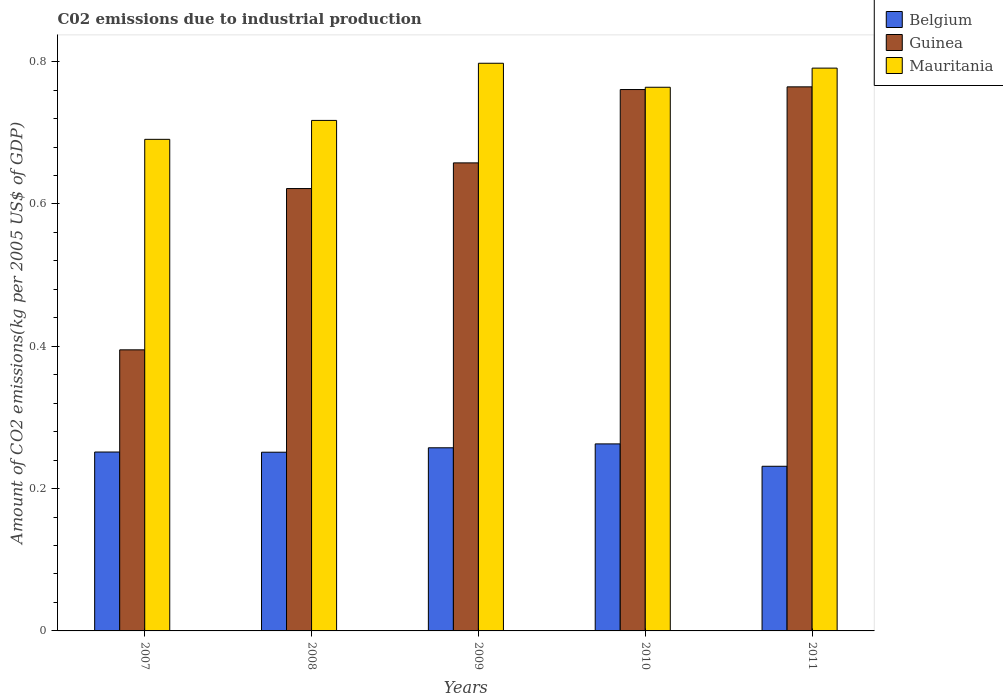How many groups of bars are there?
Make the answer very short. 5. What is the label of the 4th group of bars from the left?
Offer a very short reply. 2010. In how many cases, is the number of bars for a given year not equal to the number of legend labels?
Your answer should be compact. 0. What is the amount of CO2 emitted due to industrial production in Belgium in 2009?
Provide a short and direct response. 0.26. Across all years, what is the maximum amount of CO2 emitted due to industrial production in Mauritania?
Keep it short and to the point. 0.8. Across all years, what is the minimum amount of CO2 emitted due to industrial production in Belgium?
Ensure brevity in your answer.  0.23. In which year was the amount of CO2 emitted due to industrial production in Guinea minimum?
Keep it short and to the point. 2007. What is the total amount of CO2 emitted due to industrial production in Guinea in the graph?
Ensure brevity in your answer.  3.2. What is the difference between the amount of CO2 emitted due to industrial production in Belgium in 2009 and that in 2010?
Keep it short and to the point. -0.01. What is the difference between the amount of CO2 emitted due to industrial production in Guinea in 2008 and the amount of CO2 emitted due to industrial production in Mauritania in 2010?
Provide a succinct answer. -0.14. What is the average amount of CO2 emitted due to industrial production in Guinea per year?
Offer a very short reply. 0.64. In the year 2011, what is the difference between the amount of CO2 emitted due to industrial production in Belgium and amount of CO2 emitted due to industrial production in Mauritania?
Provide a succinct answer. -0.56. What is the ratio of the amount of CO2 emitted due to industrial production in Mauritania in 2008 to that in 2011?
Make the answer very short. 0.91. Is the difference between the amount of CO2 emitted due to industrial production in Belgium in 2008 and 2011 greater than the difference between the amount of CO2 emitted due to industrial production in Mauritania in 2008 and 2011?
Offer a very short reply. Yes. What is the difference between the highest and the second highest amount of CO2 emitted due to industrial production in Mauritania?
Make the answer very short. 0.01. What is the difference between the highest and the lowest amount of CO2 emitted due to industrial production in Belgium?
Your answer should be very brief. 0.03. What does the 1st bar from the right in 2011 represents?
Provide a short and direct response. Mauritania. Where does the legend appear in the graph?
Your answer should be compact. Top right. How are the legend labels stacked?
Make the answer very short. Vertical. What is the title of the graph?
Offer a terse response. C02 emissions due to industrial production. Does "France" appear as one of the legend labels in the graph?
Make the answer very short. No. What is the label or title of the Y-axis?
Keep it short and to the point. Amount of CO2 emissions(kg per 2005 US$ of GDP). What is the Amount of CO2 emissions(kg per 2005 US$ of GDP) in Belgium in 2007?
Your answer should be very brief. 0.25. What is the Amount of CO2 emissions(kg per 2005 US$ of GDP) of Guinea in 2007?
Give a very brief answer. 0.4. What is the Amount of CO2 emissions(kg per 2005 US$ of GDP) of Mauritania in 2007?
Ensure brevity in your answer.  0.69. What is the Amount of CO2 emissions(kg per 2005 US$ of GDP) of Belgium in 2008?
Make the answer very short. 0.25. What is the Amount of CO2 emissions(kg per 2005 US$ of GDP) in Guinea in 2008?
Ensure brevity in your answer.  0.62. What is the Amount of CO2 emissions(kg per 2005 US$ of GDP) of Mauritania in 2008?
Ensure brevity in your answer.  0.72. What is the Amount of CO2 emissions(kg per 2005 US$ of GDP) of Belgium in 2009?
Make the answer very short. 0.26. What is the Amount of CO2 emissions(kg per 2005 US$ of GDP) of Guinea in 2009?
Keep it short and to the point. 0.66. What is the Amount of CO2 emissions(kg per 2005 US$ of GDP) in Mauritania in 2009?
Your answer should be compact. 0.8. What is the Amount of CO2 emissions(kg per 2005 US$ of GDP) in Belgium in 2010?
Give a very brief answer. 0.26. What is the Amount of CO2 emissions(kg per 2005 US$ of GDP) of Guinea in 2010?
Keep it short and to the point. 0.76. What is the Amount of CO2 emissions(kg per 2005 US$ of GDP) in Mauritania in 2010?
Your response must be concise. 0.76. What is the Amount of CO2 emissions(kg per 2005 US$ of GDP) in Belgium in 2011?
Give a very brief answer. 0.23. What is the Amount of CO2 emissions(kg per 2005 US$ of GDP) in Guinea in 2011?
Offer a terse response. 0.76. What is the Amount of CO2 emissions(kg per 2005 US$ of GDP) of Mauritania in 2011?
Your response must be concise. 0.79. Across all years, what is the maximum Amount of CO2 emissions(kg per 2005 US$ of GDP) in Belgium?
Provide a short and direct response. 0.26. Across all years, what is the maximum Amount of CO2 emissions(kg per 2005 US$ of GDP) in Guinea?
Give a very brief answer. 0.76. Across all years, what is the maximum Amount of CO2 emissions(kg per 2005 US$ of GDP) of Mauritania?
Provide a succinct answer. 0.8. Across all years, what is the minimum Amount of CO2 emissions(kg per 2005 US$ of GDP) of Belgium?
Give a very brief answer. 0.23. Across all years, what is the minimum Amount of CO2 emissions(kg per 2005 US$ of GDP) in Guinea?
Give a very brief answer. 0.4. Across all years, what is the minimum Amount of CO2 emissions(kg per 2005 US$ of GDP) of Mauritania?
Your answer should be very brief. 0.69. What is the total Amount of CO2 emissions(kg per 2005 US$ of GDP) in Belgium in the graph?
Keep it short and to the point. 1.25. What is the total Amount of CO2 emissions(kg per 2005 US$ of GDP) of Mauritania in the graph?
Your answer should be compact. 3.76. What is the difference between the Amount of CO2 emissions(kg per 2005 US$ of GDP) of Belgium in 2007 and that in 2008?
Your response must be concise. 0. What is the difference between the Amount of CO2 emissions(kg per 2005 US$ of GDP) in Guinea in 2007 and that in 2008?
Offer a terse response. -0.23. What is the difference between the Amount of CO2 emissions(kg per 2005 US$ of GDP) in Mauritania in 2007 and that in 2008?
Your response must be concise. -0.03. What is the difference between the Amount of CO2 emissions(kg per 2005 US$ of GDP) in Belgium in 2007 and that in 2009?
Your answer should be compact. -0.01. What is the difference between the Amount of CO2 emissions(kg per 2005 US$ of GDP) in Guinea in 2007 and that in 2009?
Make the answer very short. -0.26. What is the difference between the Amount of CO2 emissions(kg per 2005 US$ of GDP) of Mauritania in 2007 and that in 2009?
Give a very brief answer. -0.11. What is the difference between the Amount of CO2 emissions(kg per 2005 US$ of GDP) in Belgium in 2007 and that in 2010?
Your answer should be very brief. -0.01. What is the difference between the Amount of CO2 emissions(kg per 2005 US$ of GDP) of Guinea in 2007 and that in 2010?
Your response must be concise. -0.37. What is the difference between the Amount of CO2 emissions(kg per 2005 US$ of GDP) of Mauritania in 2007 and that in 2010?
Your answer should be compact. -0.07. What is the difference between the Amount of CO2 emissions(kg per 2005 US$ of GDP) in Belgium in 2007 and that in 2011?
Offer a very short reply. 0.02. What is the difference between the Amount of CO2 emissions(kg per 2005 US$ of GDP) of Guinea in 2007 and that in 2011?
Your response must be concise. -0.37. What is the difference between the Amount of CO2 emissions(kg per 2005 US$ of GDP) of Mauritania in 2007 and that in 2011?
Offer a very short reply. -0.1. What is the difference between the Amount of CO2 emissions(kg per 2005 US$ of GDP) in Belgium in 2008 and that in 2009?
Make the answer very short. -0.01. What is the difference between the Amount of CO2 emissions(kg per 2005 US$ of GDP) in Guinea in 2008 and that in 2009?
Make the answer very short. -0.04. What is the difference between the Amount of CO2 emissions(kg per 2005 US$ of GDP) in Mauritania in 2008 and that in 2009?
Your answer should be very brief. -0.08. What is the difference between the Amount of CO2 emissions(kg per 2005 US$ of GDP) in Belgium in 2008 and that in 2010?
Make the answer very short. -0.01. What is the difference between the Amount of CO2 emissions(kg per 2005 US$ of GDP) of Guinea in 2008 and that in 2010?
Keep it short and to the point. -0.14. What is the difference between the Amount of CO2 emissions(kg per 2005 US$ of GDP) of Mauritania in 2008 and that in 2010?
Your answer should be compact. -0.05. What is the difference between the Amount of CO2 emissions(kg per 2005 US$ of GDP) of Belgium in 2008 and that in 2011?
Give a very brief answer. 0.02. What is the difference between the Amount of CO2 emissions(kg per 2005 US$ of GDP) in Guinea in 2008 and that in 2011?
Your answer should be very brief. -0.14. What is the difference between the Amount of CO2 emissions(kg per 2005 US$ of GDP) in Mauritania in 2008 and that in 2011?
Make the answer very short. -0.07. What is the difference between the Amount of CO2 emissions(kg per 2005 US$ of GDP) of Belgium in 2009 and that in 2010?
Provide a succinct answer. -0.01. What is the difference between the Amount of CO2 emissions(kg per 2005 US$ of GDP) in Guinea in 2009 and that in 2010?
Your answer should be compact. -0.1. What is the difference between the Amount of CO2 emissions(kg per 2005 US$ of GDP) of Mauritania in 2009 and that in 2010?
Your answer should be compact. 0.03. What is the difference between the Amount of CO2 emissions(kg per 2005 US$ of GDP) of Belgium in 2009 and that in 2011?
Your response must be concise. 0.03. What is the difference between the Amount of CO2 emissions(kg per 2005 US$ of GDP) in Guinea in 2009 and that in 2011?
Your response must be concise. -0.11. What is the difference between the Amount of CO2 emissions(kg per 2005 US$ of GDP) of Mauritania in 2009 and that in 2011?
Keep it short and to the point. 0.01. What is the difference between the Amount of CO2 emissions(kg per 2005 US$ of GDP) of Belgium in 2010 and that in 2011?
Your answer should be very brief. 0.03. What is the difference between the Amount of CO2 emissions(kg per 2005 US$ of GDP) of Guinea in 2010 and that in 2011?
Make the answer very short. -0. What is the difference between the Amount of CO2 emissions(kg per 2005 US$ of GDP) of Mauritania in 2010 and that in 2011?
Offer a very short reply. -0.03. What is the difference between the Amount of CO2 emissions(kg per 2005 US$ of GDP) of Belgium in 2007 and the Amount of CO2 emissions(kg per 2005 US$ of GDP) of Guinea in 2008?
Provide a succinct answer. -0.37. What is the difference between the Amount of CO2 emissions(kg per 2005 US$ of GDP) in Belgium in 2007 and the Amount of CO2 emissions(kg per 2005 US$ of GDP) in Mauritania in 2008?
Provide a short and direct response. -0.47. What is the difference between the Amount of CO2 emissions(kg per 2005 US$ of GDP) of Guinea in 2007 and the Amount of CO2 emissions(kg per 2005 US$ of GDP) of Mauritania in 2008?
Offer a very short reply. -0.32. What is the difference between the Amount of CO2 emissions(kg per 2005 US$ of GDP) in Belgium in 2007 and the Amount of CO2 emissions(kg per 2005 US$ of GDP) in Guinea in 2009?
Give a very brief answer. -0.41. What is the difference between the Amount of CO2 emissions(kg per 2005 US$ of GDP) in Belgium in 2007 and the Amount of CO2 emissions(kg per 2005 US$ of GDP) in Mauritania in 2009?
Offer a very short reply. -0.55. What is the difference between the Amount of CO2 emissions(kg per 2005 US$ of GDP) of Guinea in 2007 and the Amount of CO2 emissions(kg per 2005 US$ of GDP) of Mauritania in 2009?
Make the answer very short. -0.4. What is the difference between the Amount of CO2 emissions(kg per 2005 US$ of GDP) in Belgium in 2007 and the Amount of CO2 emissions(kg per 2005 US$ of GDP) in Guinea in 2010?
Your answer should be very brief. -0.51. What is the difference between the Amount of CO2 emissions(kg per 2005 US$ of GDP) of Belgium in 2007 and the Amount of CO2 emissions(kg per 2005 US$ of GDP) of Mauritania in 2010?
Your response must be concise. -0.51. What is the difference between the Amount of CO2 emissions(kg per 2005 US$ of GDP) of Guinea in 2007 and the Amount of CO2 emissions(kg per 2005 US$ of GDP) of Mauritania in 2010?
Provide a succinct answer. -0.37. What is the difference between the Amount of CO2 emissions(kg per 2005 US$ of GDP) in Belgium in 2007 and the Amount of CO2 emissions(kg per 2005 US$ of GDP) in Guinea in 2011?
Ensure brevity in your answer.  -0.51. What is the difference between the Amount of CO2 emissions(kg per 2005 US$ of GDP) of Belgium in 2007 and the Amount of CO2 emissions(kg per 2005 US$ of GDP) of Mauritania in 2011?
Ensure brevity in your answer.  -0.54. What is the difference between the Amount of CO2 emissions(kg per 2005 US$ of GDP) in Guinea in 2007 and the Amount of CO2 emissions(kg per 2005 US$ of GDP) in Mauritania in 2011?
Offer a terse response. -0.4. What is the difference between the Amount of CO2 emissions(kg per 2005 US$ of GDP) of Belgium in 2008 and the Amount of CO2 emissions(kg per 2005 US$ of GDP) of Guinea in 2009?
Keep it short and to the point. -0.41. What is the difference between the Amount of CO2 emissions(kg per 2005 US$ of GDP) in Belgium in 2008 and the Amount of CO2 emissions(kg per 2005 US$ of GDP) in Mauritania in 2009?
Offer a very short reply. -0.55. What is the difference between the Amount of CO2 emissions(kg per 2005 US$ of GDP) in Guinea in 2008 and the Amount of CO2 emissions(kg per 2005 US$ of GDP) in Mauritania in 2009?
Offer a very short reply. -0.18. What is the difference between the Amount of CO2 emissions(kg per 2005 US$ of GDP) in Belgium in 2008 and the Amount of CO2 emissions(kg per 2005 US$ of GDP) in Guinea in 2010?
Your response must be concise. -0.51. What is the difference between the Amount of CO2 emissions(kg per 2005 US$ of GDP) of Belgium in 2008 and the Amount of CO2 emissions(kg per 2005 US$ of GDP) of Mauritania in 2010?
Your response must be concise. -0.51. What is the difference between the Amount of CO2 emissions(kg per 2005 US$ of GDP) in Guinea in 2008 and the Amount of CO2 emissions(kg per 2005 US$ of GDP) in Mauritania in 2010?
Offer a very short reply. -0.14. What is the difference between the Amount of CO2 emissions(kg per 2005 US$ of GDP) of Belgium in 2008 and the Amount of CO2 emissions(kg per 2005 US$ of GDP) of Guinea in 2011?
Ensure brevity in your answer.  -0.51. What is the difference between the Amount of CO2 emissions(kg per 2005 US$ of GDP) in Belgium in 2008 and the Amount of CO2 emissions(kg per 2005 US$ of GDP) in Mauritania in 2011?
Your response must be concise. -0.54. What is the difference between the Amount of CO2 emissions(kg per 2005 US$ of GDP) of Guinea in 2008 and the Amount of CO2 emissions(kg per 2005 US$ of GDP) of Mauritania in 2011?
Offer a terse response. -0.17. What is the difference between the Amount of CO2 emissions(kg per 2005 US$ of GDP) of Belgium in 2009 and the Amount of CO2 emissions(kg per 2005 US$ of GDP) of Guinea in 2010?
Provide a short and direct response. -0.5. What is the difference between the Amount of CO2 emissions(kg per 2005 US$ of GDP) of Belgium in 2009 and the Amount of CO2 emissions(kg per 2005 US$ of GDP) of Mauritania in 2010?
Give a very brief answer. -0.51. What is the difference between the Amount of CO2 emissions(kg per 2005 US$ of GDP) of Guinea in 2009 and the Amount of CO2 emissions(kg per 2005 US$ of GDP) of Mauritania in 2010?
Your answer should be compact. -0.11. What is the difference between the Amount of CO2 emissions(kg per 2005 US$ of GDP) of Belgium in 2009 and the Amount of CO2 emissions(kg per 2005 US$ of GDP) of Guinea in 2011?
Your answer should be compact. -0.51. What is the difference between the Amount of CO2 emissions(kg per 2005 US$ of GDP) of Belgium in 2009 and the Amount of CO2 emissions(kg per 2005 US$ of GDP) of Mauritania in 2011?
Give a very brief answer. -0.53. What is the difference between the Amount of CO2 emissions(kg per 2005 US$ of GDP) of Guinea in 2009 and the Amount of CO2 emissions(kg per 2005 US$ of GDP) of Mauritania in 2011?
Your answer should be compact. -0.13. What is the difference between the Amount of CO2 emissions(kg per 2005 US$ of GDP) in Belgium in 2010 and the Amount of CO2 emissions(kg per 2005 US$ of GDP) in Guinea in 2011?
Keep it short and to the point. -0.5. What is the difference between the Amount of CO2 emissions(kg per 2005 US$ of GDP) in Belgium in 2010 and the Amount of CO2 emissions(kg per 2005 US$ of GDP) in Mauritania in 2011?
Your response must be concise. -0.53. What is the difference between the Amount of CO2 emissions(kg per 2005 US$ of GDP) in Guinea in 2010 and the Amount of CO2 emissions(kg per 2005 US$ of GDP) in Mauritania in 2011?
Make the answer very short. -0.03. What is the average Amount of CO2 emissions(kg per 2005 US$ of GDP) of Belgium per year?
Ensure brevity in your answer.  0.25. What is the average Amount of CO2 emissions(kg per 2005 US$ of GDP) of Guinea per year?
Ensure brevity in your answer.  0.64. What is the average Amount of CO2 emissions(kg per 2005 US$ of GDP) in Mauritania per year?
Give a very brief answer. 0.75. In the year 2007, what is the difference between the Amount of CO2 emissions(kg per 2005 US$ of GDP) of Belgium and Amount of CO2 emissions(kg per 2005 US$ of GDP) of Guinea?
Ensure brevity in your answer.  -0.14. In the year 2007, what is the difference between the Amount of CO2 emissions(kg per 2005 US$ of GDP) of Belgium and Amount of CO2 emissions(kg per 2005 US$ of GDP) of Mauritania?
Give a very brief answer. -0.44. In the year 2007, what is the difference between the Amount of CO2 emissions(kg per 2005 US$ of GDP) of Guinea and Amount of CO2 emissions(kg per 2005 US$ of GDP) of Mauritania?
Offer a very short reply. -0.3. In the year 2008, what is the difference between the Amount of CO2 emissions(kg per 2005 US$ of GDP) in Belgium and Amount of CO2 emissions(kg per 2005 US$ of GDP) in Guinea?
Your answer should be very brief. -0.37. In the year 2008, what is the difference between the Amount of CO2 emissions(kg per 2005 US$ of GDP) of Belgium and Amount of CO2 emissions(kg per 2005 US$ of GDP) of Mauritania?
Give a very brief answer. -0.47. In the year 2008, what is the difference between the Amount of CO2 emissions(kg per 2005 US$ of GDP) of Guinea and Amount of CO2 emissions(kg per 2005 US$ of GDP) of Mauritania?
Offer a very short reply. -0.1. In the year 2009, what is the difference between the Amount of CO2 emissions(kg per 2005 US$ of GDP) of Belgium and Amount of CO2 emissions(kg per 2005 US$ of GDP) of Guinea?
Give a very brief answer. -0.4. In the year 2009, what is the difference between the Amount of CO2 emissions(kg per 2005 US$ of GDP) in Belgium and Amount of CO2 emissions(kg per 2005 US$ of GDP) in Mauritania?
Give a very brief answer. -0.54. In the year 2009, what is the difference between the Amount of CO2 emissions(kg per 2005 US$ of GDP) in Guinea and Amount of CO2 emissions(kg per 2005 US$ of GDP) in Mauritania?
Your answer should be compact. -0.14. In the year 2010, what is the difference between the Amount of CO2 emissions(kg per 2005 US$ of GDP) of Belgium and Amount of CO2 emissions(kg per 2005 US$ of GDP) of Guinea?
Provide a short and direct response. -0.5. In the year 2010, what is the difference between the Amount of CO2 emissions(kg per 2005 US$ of GDP) in Belgium and Amount of CO2 emissions(kg per 2005 US$ of GDP) in Mauritania?
Your answer should be compact. -0.5. In the year 2010, what is the difference between the Amount of CO2 emissions(kg per 2005 US$ of GDP) of Guinea and Amount of CO2 emissions(kg per 2005 US$ of GDP) of Mauritania?
Your response must be concise. -0. In the year 2011, what is the difference between the Amount of CO2 emissions(kg per 2005 US$ of GDP) of Belgium and Amount of CO2 emissions(kg per 2005 US$ of GDP) of Guinea?
Ensure brevity in your answer.  -0.53. In the year 2011, what is the difference between the Amount of CO2 emissions(kg per 2005 US$ of GDP) in Belgium and Amount of CO2 emissions(kg per 2005 US$ of GDP) in Mauritania?
Provide a short and direct response. -0.56. In the year 2011, what is the difference between the Amount of CO2 emissions(kg per 2005 US$ of GDP) of Guinea and Amount of CO2 emissions(kg per 2005 US$ of GDP) of Mauritania?
Provide a short and direct response. -0.03. What is the ratio of the Amount of CO2 emissions(kg per 2005 US$ of GDP) in Guinea in 2007 to that in 2008?
Make the answer very short. 0.64. What is the ratio of the Amount of CO2 emissions(kg per 2005 US$ of GDP) in Mauritania in 2007 to that in 2008?
Offer a terse response. 0.96. What is the ratio of the Amount of CO2 emissions(kg per 2005 US$ of GDP) in Belgium in 2007 to that in 2009?
Provide a short and direct response. 0.98. What is the ratio of the Amount of CO2 emissions(kg per 2005 US$ of GDP) of Guinea in 2007 to that in 2009?
Make the answer very short. 0.6. What is the ratio of the Amount of CO2 emissions(kg per 2005 US$ of GDP) in Mauritania in 2007 to that in 2009?
Provide a succinct answer. 0.87. What is the ratio of the Amount of CO2 emissions(kg per 2005 US$ of GDP) in Belgium in 2007 to that in 2010?
Ensure brevity in your answer.  0.96. What is the ratio of the Amount of CO2 emissions(kg per 2005 US$ of GDP) in Guinea in 2007 to that in 2010?
Your response must be concise. 0.52. What is the ratio of the Amount of CO2 emissions(kg per 2005 US$ of GDP) of Mauritania in 2007 to that in 2010?
Your response must be concise. 0.9. What is the ratio of the Amount of CO2 emissions(kg per 2005 US$ of GDP) in Belgium in 2007 to that in 2011?
Offer a very short reply. 1.09. What is the ratio of the Amount of CO2 emissions(kg per 2005 US$ of GDP) of Guinea in 2007 to that in 2011?
Provide a short and direct response. 0.52. What is the ratio of the Amount of CO2 emissions(kg per 2005 US$ of GDP) in Mauritania in 2007 to that in 2011?
Your answer should be very brief. 0.87. What is the ratio of the Amount of CO2 emissions(kg per 2005 US$ of GDP) in Belgium in 2008 to that in 2009?
Your answer should be very brief. 0.98. What is the ratio of the Amount of CO2 emissions(kg per 2005 US$ of GDP) in Guinea in 2008 to that in 2009?
Provide a short and direct response. 0.95. What is the ratio of the Amount of CO2 emissions(kg per 2005 US$ of GDP) of Mauritania in 2008 to that in 2009?
Give a very brief answer. 0.9. What is the ratio of the Amount of CO2 emissions(kg per 2005 US$ of GDP) of Belgium in 2008 to that in 2010?
Your answer should be very brief. 0.96. What is the ratio of the Amount of CO2 emissions(kg per 2005 US$ of GDP) in Guinea in 2008 to that in 2010?
Offer a terse response. 0.82. What is the ratio of the Amount of CO2 emissions(kg per 2005 US$ of GDP) in Mauritania in 2008 to that in 2010?
Your answer should be compact. 0.94. What is the ratio of the Amount of CO2 emissions(kg per 2005 US$ of GDP) in Belgium in 2008 to that in 2011?
Keep it short and to the point. 1.09. What is the ratio of the Amount of CO2 emissions(kg per 2005 US$ of GDP) in Guinea in 2008 to that in 2011?
Keep it short and to the point. 0.81. What is the ratio of the Amount of CO2 emissions(kg per 2005 US$ of GDP) of Mauritania in 2008 to that in 2011?
Give a very brief answer. 0.91. What is the ratio of the Amount of CO2 emissions(kg per 2005 US$ of GDP) of Belgium in 2009 to that in 2010?
Your answer should be very brief. 0.98. What is the ratio of the Amount of CO2 emissions(kg per 2005 US$ of GDP) of Guinea in 2009 to that in 2010?
Your answer should be very brief. 0.86. What is the ratio of the Amount of CO2 emissions(kg per 2005 US$ of GDP) in Mauritania in 2009 to that in 2010?
Offer a terse response. 1.04. What is the ratio of the Amount of CO2 emissions(kg per 2005 US$ of GDP) in Belgium in 2009 to that in 2011?
Your response must be concise. 1.11. What is the ratio of the Amount of CO2 emissions(kg per 2005 US$ of GDP) in Guinea in 2009 to that in 2011?
Your answer should be compact. 0.86. What is the ratio of the Amount of CO2 emissions(kg per 2005 US$ of GDP) of Mauritania in 2009 to that in 2011?
Offer a very short reply. 1.01. What is the ratio of the Amount of CO2 emissions(kg per 2005 US$ of GDP) of Belgium in 2010 to that in 2011?
Provide a short and direct response. 1.14. What is the ratio of the Amount of CO2 emissions(kg per 2005 US$ of GDP) in Guinea in 2010 to that in 2011?
Provide a succinct answer. 1. What is the difference between the highest and the second highest Amount of CO2 emissions(kg per 2005 US$ of GDP) in Belgium?
Make the answer very short. 0.01. What is the difference between the highest and the second highest Amount of CO2 emissions(kg per 2005 US$ of GDP) in Guinea?
Offer a terse response. 0. What is the difference between the highest and the second highest Amount of CO2 emissions(kg per 2005 US$ of GDP) of Mauritania?
Provide a succinct answer. 0.01. What is the difference between the highest and the lowest Amount of CO2 emissions(kg per 2005 US$ of GDP) in Belgium?
Provide a short and direct response. 0.03. What is the difference between the highest and the lowest Amount of CO2 emissions(kg per 2005 US$ of GDP) in Guinea?
Your response must be concise. 0.37. What is the difference between the highest and the lowest Amount of CO2 emissions(kg per 2005 US$ of GDP) of Mauritania?
Ensure brevity in your answer.  0.11. 